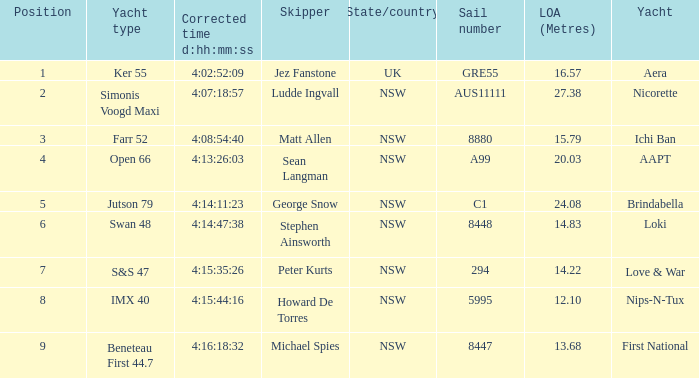Which racing boat had a corrected time of 4:14:11:23? Brindabella. I'm looking to parse the entire table for insights. Could you assist me with that? {'header': ['Position', 'Yacht type', 'Corrected time d:hh:mm:ss', 'Skipper', 'State/country', 'Sail number', 'LOA (Metres)', 'Yacht'], 'rows': [['1', 'Ker 55', '4:02:52:09', 'Jez Fanstone', 'UK', 'GRE55', '16.57', 'Aera'], ['2', 'Simonis Voogd Maxi', '4:07:18:57', 'Ludde Ingvall', 'NSW', 'AUS11111', '27.38', 'Nicorette'], ['3', 'Farr 52', '4:08:54:40', 'Matt Allen', 'NSW', '8880', '15.79', 'Ichi Ban'], ['4', 'Open 66', '4:13:26:03', 'Sean Langman', 'NSW', 'A99', '20.03', 'AAPT'], ['5', 'Jutson 79', '4:14:11:23', 'George Snow', 'NSW', 'C1', '24.08', 'Brindabella'], ['6', 'Swan 48', '4:14:47:38', 'Stephen Ainsworth', 'NSW', '8448', '14.83', 'Loki'], ['7', 'S&S 47', '4:15:35:26', 'Peter Kurts', 'NSW', '294', '14.22', 'Love & War'], ['8', 'IMX 40', '4:15:44:16', 'Howard De Torres', 'NSW', '5995', '12.10', 'Nips-N-Tux'], ['9', 'Beneteau First 44.7', '4:16:18:32', 'Michael Spies', 'NSW', '8447', '13.68', 'First National']]} 